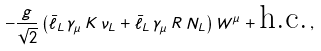<formula> <loc_0><loc_0><loc_500><loc_500>- \frac { g } { \sqrt { 2 } } \left ( \bar { \ell } _ { L } \, \gamma _ { \mu } \, K \, \nu _ { L } + \bar { \ell } _ { L } \, \gamma _ { \mu } \, R \, N _ { L } \right ) W ^ { \mu } + \text {h.c.} \, ,</formula> 